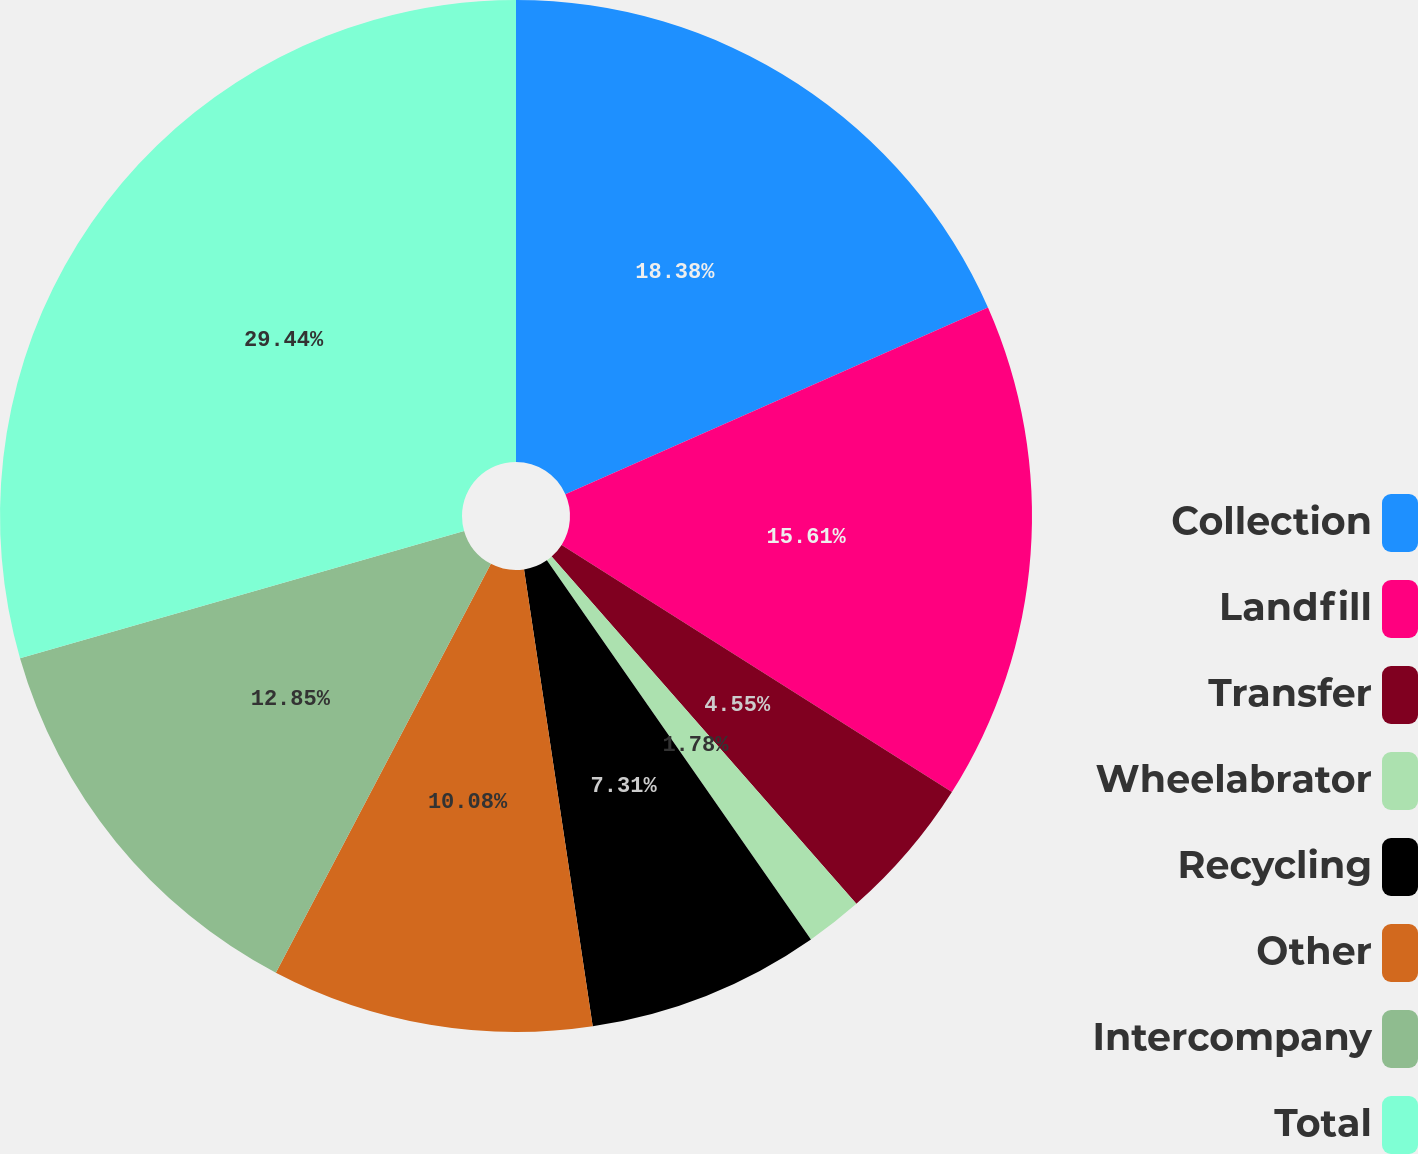Convert chart. <chart><loc_0><loc_0><loc_500><loc_500><pie_chart><fcel>Collection<fcel>Landfill<fcel>Transfer<fcel>Wheelabrator<fcel>Recycling<fcel>Other<fcel>Intercompany<fcel>Total<nl><fcel>18.38%<fcel>15.61%<fcel>4.55%<fcel>1.78%<fcel>7.31%<fcel>10.08%<fcel>12.85%<fcel>29.45%<nl></chart> 